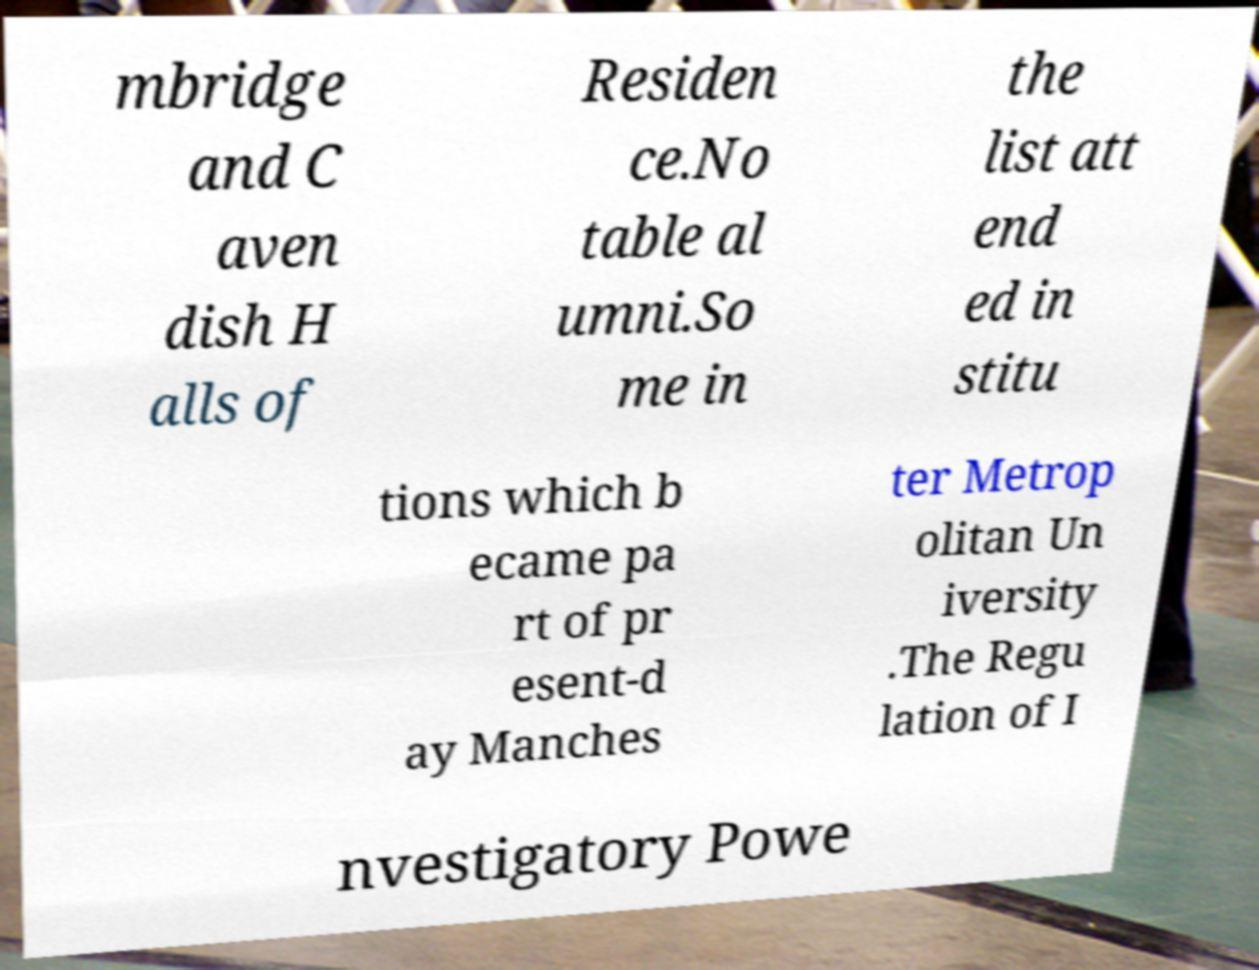Could you assist in decoding the text presented in this image and type it out clearly? mbridge and C aven dish H alls of Residen ce.No table al umni.So me in the list att end ed in stitu tions which b ecame pa rt of pr esent-d ay Manches ter Metrop olitan Un iversity .The Regu lation of I nvestigatory Powe 